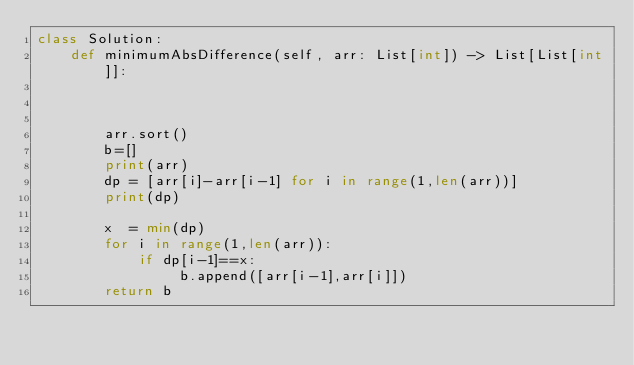<code> <loc_0><loc_0><loc_500><loc_500><_Python_>class Solution:
    def minimumAbsDifference(self, arr: List[int]) -> List[List[int]]:
        
        
        
        arr.sort()
        b=[]
        print(arr)
        dp = [arr[i]-arr[i-1] for i in range(1,len(arr))]
        print(dp)
        
        x  = min(dp)
        for i in range(1,len(arr)):
            if dp[i-1]==x:
                 b.append([arr[i-1],arr[i]])
        return b
        
         
        
</code> 